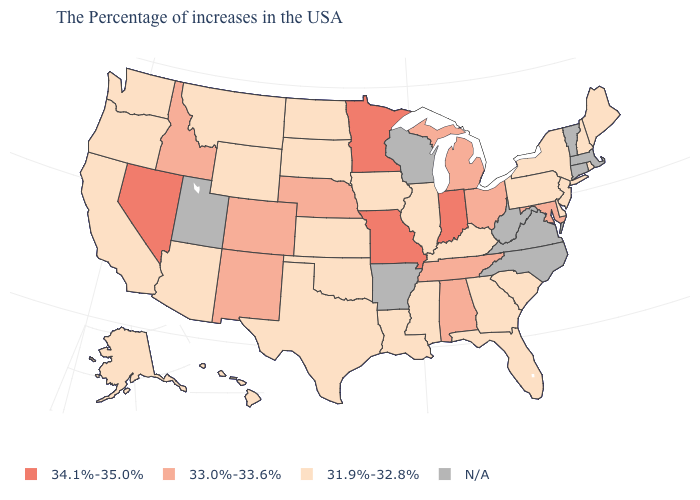What is the value of Florida?
Keep it brief. 31.9%-32.8%. What is the value of Vermont?
Write a very short answer. N/A. What is the value of Indiana?
Quick response, please. 34.1%-35.0%. Does Illinois have the highest value in the MidWest?
Give a very brief answer. No. Name the states that have a value in the range 33.0%-33.6%?
Write a very short answer. Maryland, Ohio, Michigan, Alabama, Tennessee, Nebraska, Colorado, New Mexico, Idaho. Name the states that have a value in the range 34.1%-35.0%?
Short answer required. Indiana, Missouri, Minnesota, Nevada. Name the states that have a value in the range N/A?
Short answer required. Massachusetts, Vermont, Connecticut, Virginia, North Carolina, West Virginia, Wisconsin, Arkansas, Utah. What is the value of Washington?
Keep it brief. 31.9%-32.8%. Name the states that have a value in the range 33.0%-33.6%?
Answer briefly. Maryland, Ohio, Michigan, Alabama, Tennessee, Nebraska, Colorado, New Mexico, Idaho. What is the lowest value in states that border Utah?
Short answer required. 31.9%-32.8%. Name the states that have a value in the range N/A?
Concise answer only. Massachusetts, Vermont, Connecticut, Virginia, North Carolina, West Virginia, Wisconsin, Arkansas, Utah. How many symbols are there in the legend?
Write a very short answer. 4. 